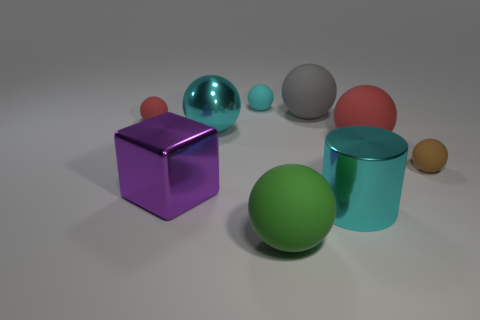Subtract all cyan balls. How many balls are left? 5 Subtract all big green balls. How many balls are left? 6 Subtract 1 balls. How many balls are left? 6 Subtract all gray spheres. Subtract all green cubes. How many spheres are left? 6 Add 1 cyan blocks. How many objects exist? 10 Subtract all blocks. How many objects are left? 8 Subtract 0 blue blocks. How many objects are left? 9 Subtract all tiny brown rubber balls. Subtract all tiny brown matte cylinders. How many objects are left? 8 Add 3 spheres. How many spheres are left? 10 Add 6 purple metal cubes. How many purple metal cubes exist? 7 